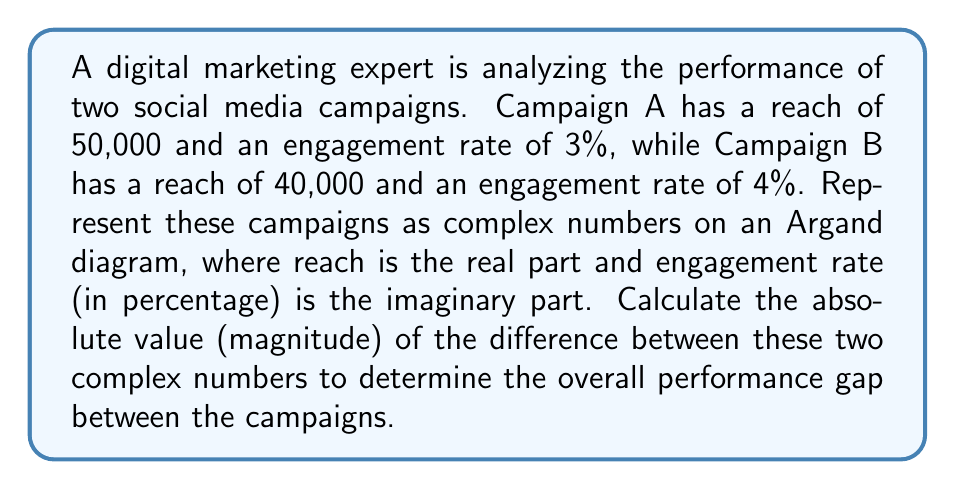Can you answer this question? Let's approach this step-by-step:

1) First, we need to represent each campaign as a complex number:
   Campaign A: $z_A = 50000 + 3i$
   Campaign B: $z_B = 40000 + 4i$

2) To find the difference between these campaigns, we subtract:
   $z_A - z_B = (50000 + 3i) - (40000 + 4i) = 10000 - i$

3) Now, we need to calculate the absolute value (magnitude) of this difference. For a complex number $z = a + bi$, the absolute value is given by:
   $|z| = \sqrt{a^2 + b^2}$

4) In our case, $a = 10000$ and $b = -1$:
   $|z_A - z_B| = \sqrt{10000^2 + (-1)^2}$

5) Simplifying:
   $|z_A - z_B| = \sqrt{100000000 + 1} = \sqrt{100000001}$

6) This can be approximated to:
   $|z_A - z_B| \approx 10000.00005$

This value represents the overall performance gap between the two campaigns in terms of both reach and engagement rate.

[asy]
import graph;
size(200);
real xmax = 60000;
real ymax = 5;

xaxis("Reach", 0, xmax, arrow=Arrow);
yaxis("Engagement Rate (%)", 0, ymax, arrow=Arrow);

dot("A", (50000,3), NE);
dot("B", (40000,4), NW);
draw((50000,3)--(40000,4), arrow=Arrow);
label("Difference", (45000,3.5), SE);
[/asy]
Answer: $10000.00005$ 